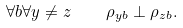Convert formula to latex. <formula><loc_0><loc_0><loc_500><loc_500>\forall b \forall y \neq z \quad \rho _ { y b } \perp \rho _ { z b } .</formula> 